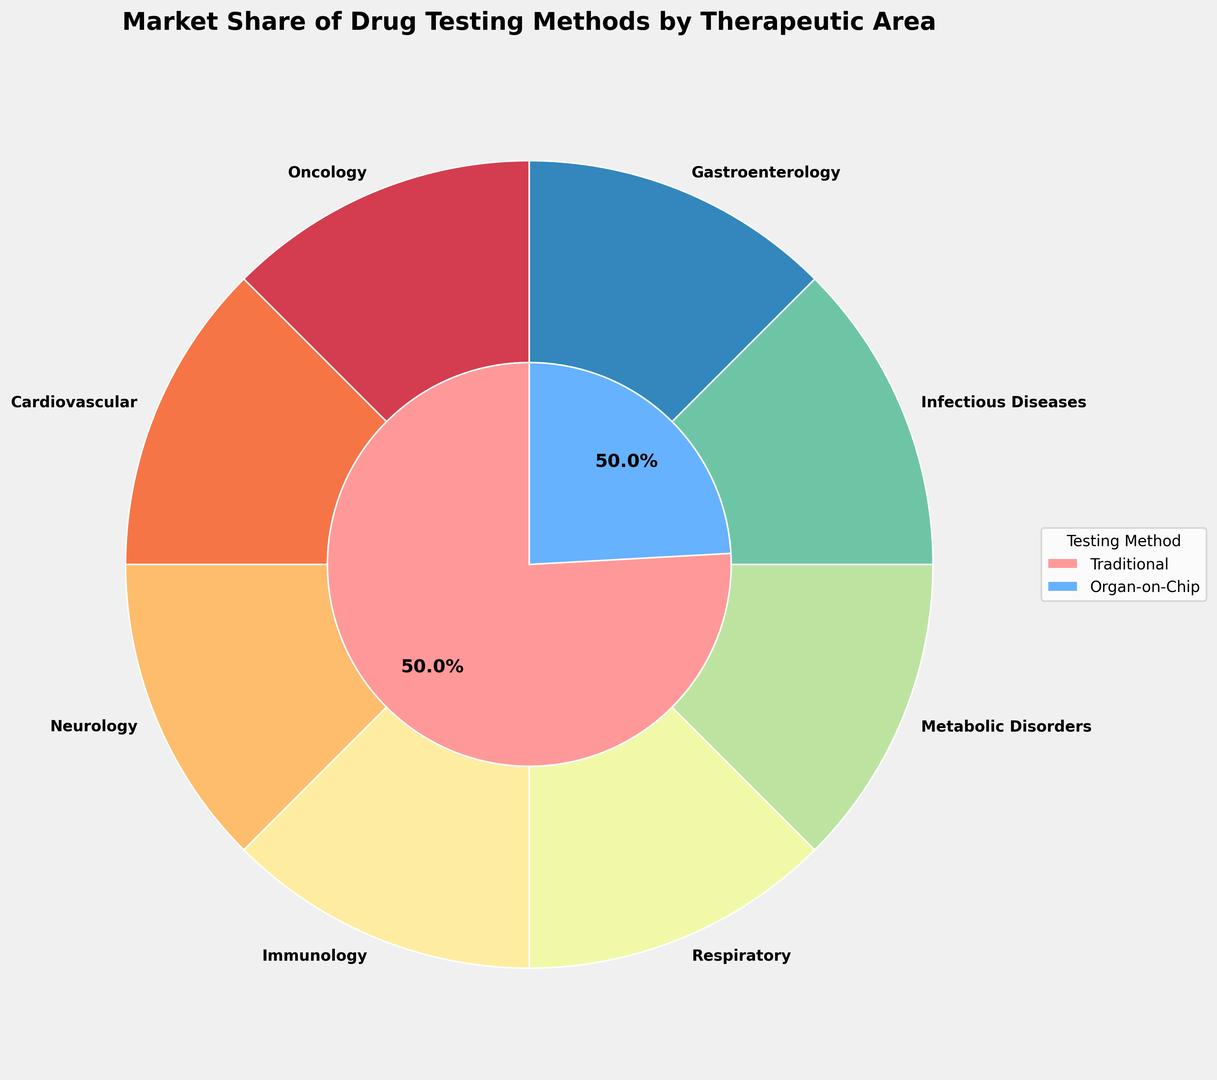What therapeutic area has the largest market share for traditional testing methods? Visually, look for the segment representing the largest portion in the outer pie chart corresponding to traditional methods.
Answer: Respiratory Which testing method has a greater total market share across all therapeutic areas? Observe the inner pie chart. The segment with the larger market share will be evident by the larger size.
Answer: Traditional What is the combined market share of organ-on-chip technology in Oncology and Immunology? Add the market shares represented by the organ-on-chip segments for Oncology (35%) and Immunology (30%).
Answer: 65% In which therapeutic area does organ-on-chip technology have the lowest market share? Find the smallest segment in the outer pie chart corresponding to organ-on-chip technology.
Answer: Respiratory How does the market share of traditional testing methods in Neurology compare to Metabolic Disorders? Check the figure for the visual sizes of the segments corresponding to Neurology (80%) and Metabolic Disorders (78%).
Answer: Greater for Neurology What is the ratio of the market share of traditional methods to organ-on-chip technology in Infectious Diseases? Divide the market share of traditional methods (82%) by that of organ-on-chip technology (18%).
Answer: About 4.6 Which therapeutic areas have traditional testing methods with a market share greater than 75%? Identify the segments in the outer pie chart where the share for traditional methods is greater than 75%: Cardiovascular (75+), Neurology (80), Respiratory (85), Infectious Diseases (82), Metabolic Disorders (78).
Answer: Neurology, Respiratory, Infectious Diseases, Metabolic Disorders What is the average market share of organ-on-chip technology across all therapeutic areas? Sum the market shares for organ-on-chip technology (35 + 25 + 20 + 30 + 15 + 22 + 18 + 28) and divide by the number of areas (8). The average is (193 / 8).
Answer: 24.125% What therapeutic area has the smallest discrepancy between the market shares of traditional and organ-on-chip methods? Calculate the difference for each therapeutic area: Oncology (30), Cardiovascular (50), Neurology (60), Immunology (40), Respiratory (70), Metabolic Disorders (56), Infectious Diseases (64), Gastroenterology (44). The smallest discrepancy is for Oncology (30).
Answer: Oncology 